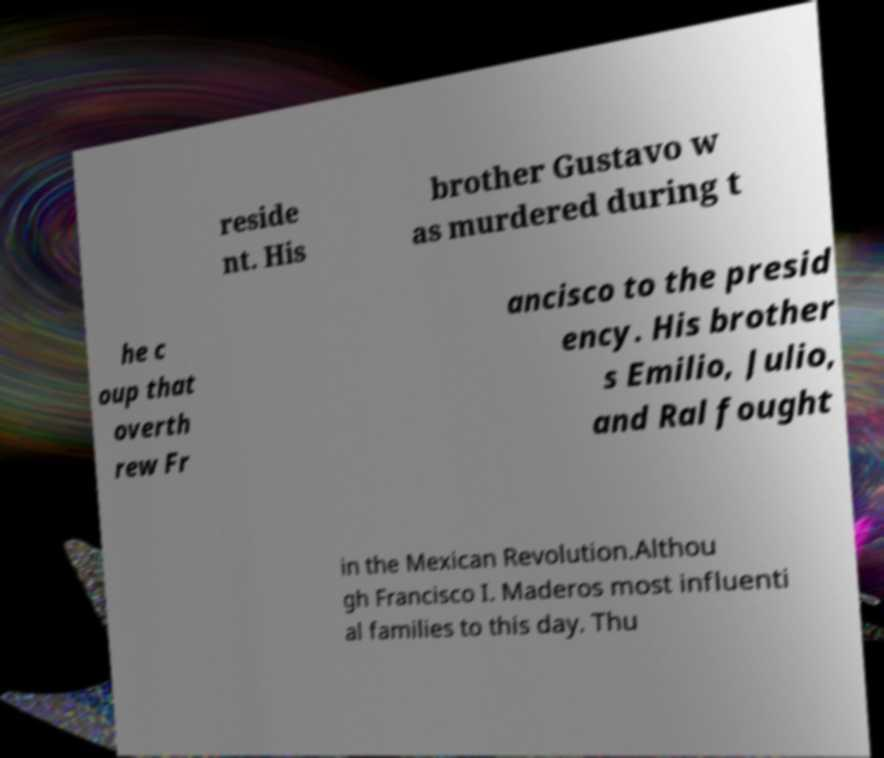Please identify and transcribe the text found in this image. reside nt. His brother Gustavo w as murdered during t he c oup that overth rew Fr ancisco to the presid ency. His brother s Emilio, Julio, and Ral fought in the Mexican Revolution.Althou gh Francisco I. Maderos most influenti al families to this day. Thu 